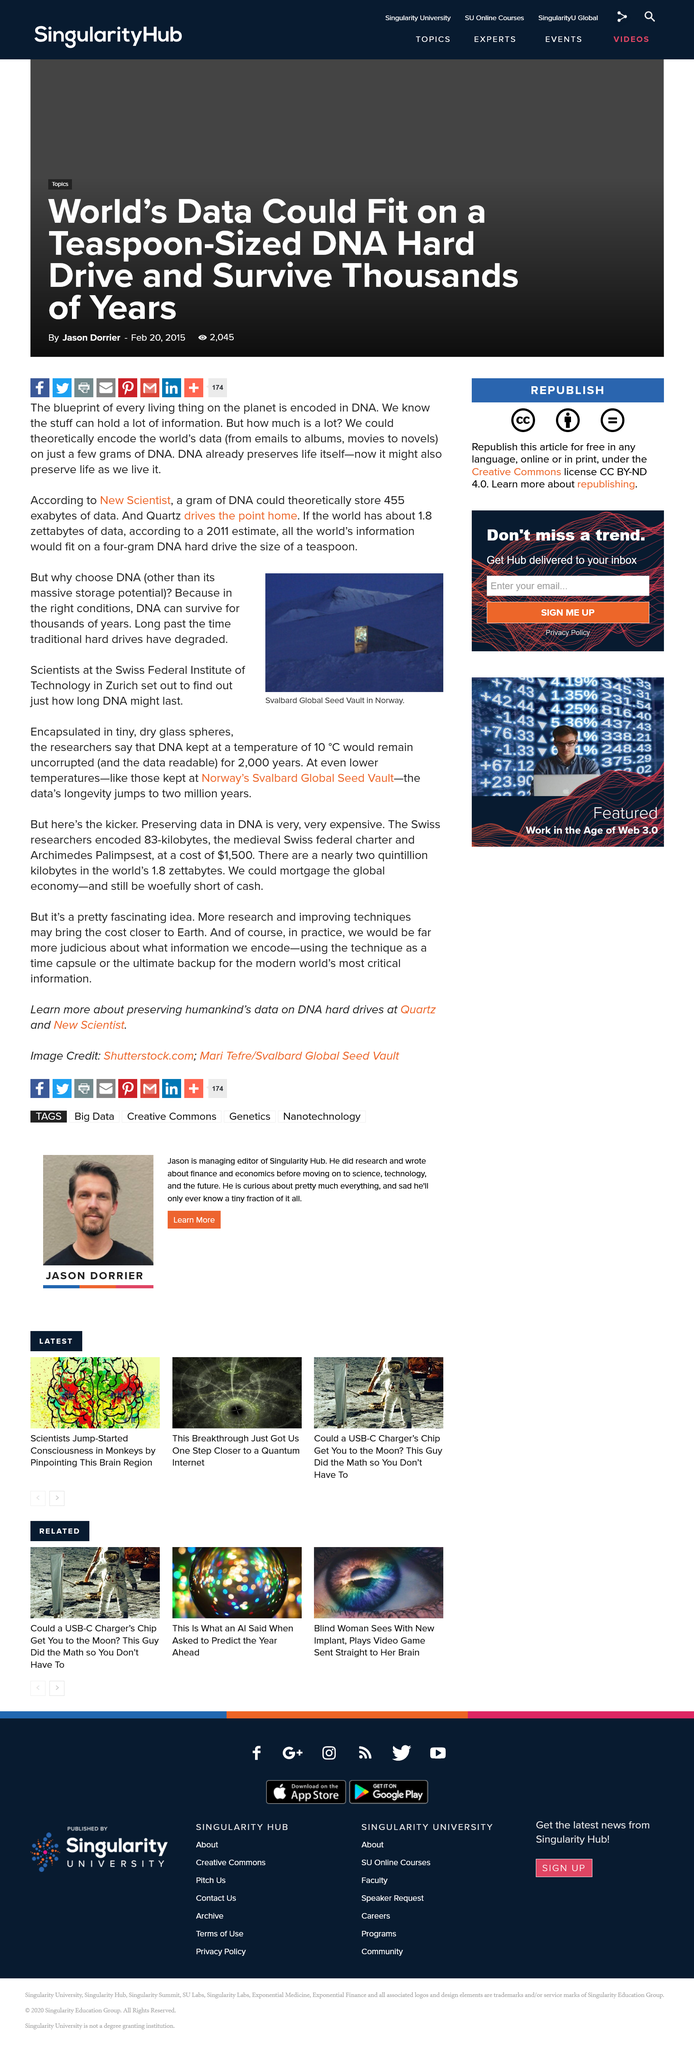List a handful of essential elements in this visual. The Svalbard Global Seed Vault in Norway is depicted in the image provided. Researchers at the Swiss Federal Institute of Technology in Zurich set out to determine the longevity of DNA. I declare that DNA can survive for thousands of years in the right conditions. 